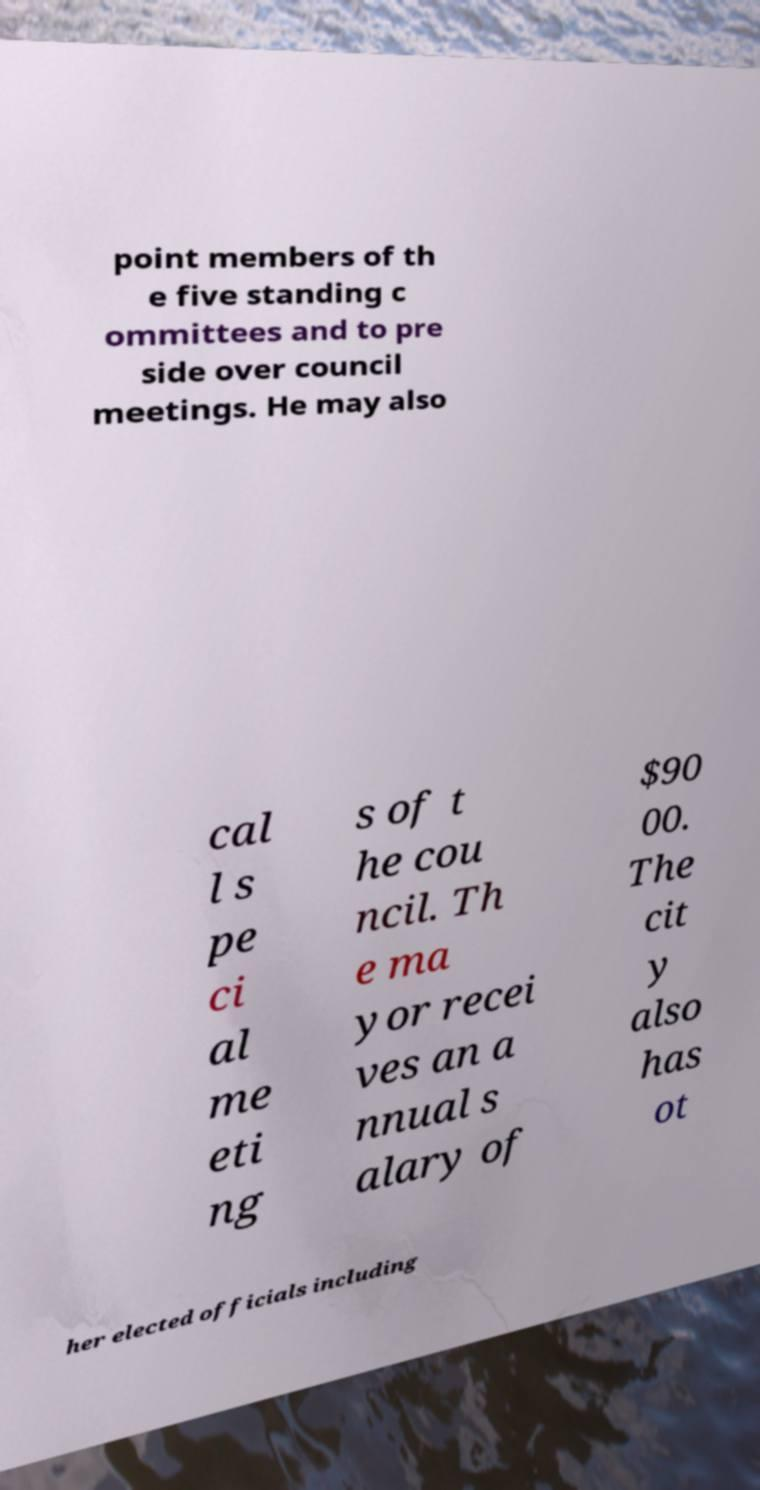I need the written content from this picture converted into text. Can you do that? point members of th e five standing c ommittees and to pre side over council meetings. He may also cal l s pe ci al me eti ng s of t he cou ncil. Th e ma yor recei ves an a nnual s alary of $90 00. The cit y also has ot her elected officials including 